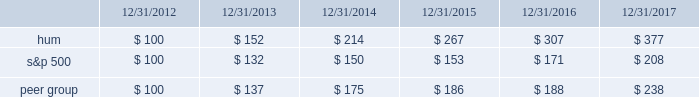Stock total return performance the following graph compares our total return to stockholders with the returns of the standard & poor 2019s composite 500 index ( 201cs&p 500 201d ) and the dow jones us select health care providers index ( 201cpeer group 201d ) for the five years ended december 31 , 2017 .
The graph assumes an investment of $ 100 in each of our common stock , the s&p 500 , and the peer group on december 31 , 2012 , and that dividends were reinvested when paid. .
The stock price performance included in this graph is not necessarily indicative of future stock price performance. .
What was the percent of the growth in the stock total return performance for hum from 2013 to 2014? 
Rationale: the stock total return performance for hum increased by 41% from 2013 to 2014
Computations: (214 - 152)
Answer: 62.0. Stock total return performance the following graph compares our total return to stockholders with the returns of the standard & poor 2019s composite 500 index ( 201cs&p 500 201d ) and the dow jones us select health care providers index ( 201cpeer group 201d ) for the five years ended december 31 , 2017 .
The graph assumes an investment of $ 100 in each of our common stock , the s&p 500 , and the peer group on december 31 , 2012 , and that dividends were reinvested when paid. .
The stock price performance included in this graph is not necessarily indicative of future stock price performance. .
What is the highest return for the second year of the investment? 
Rationale: it is the maximum value of the investment in the second year , then turned into a percentage .
Computations: (214 - 100)
Answer: 114.0. 